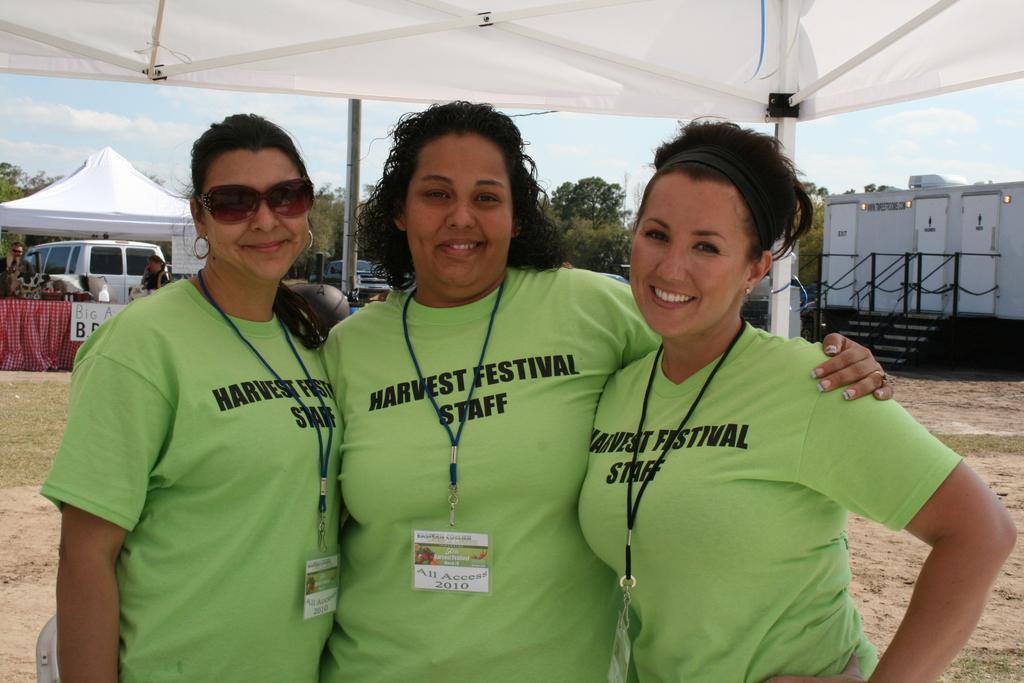Please provide a concise description of this image. This image is taken outdoors. At the top of the image there is a tent. In the background there are many trees and there is a sky with clouds. A few vehicles are parked on the ground. On the right side of the image there are a few restrooms and there is a railing. On the left side of the image there is a tent and there is a table with a tablecloth on it and there is a board with a text on it. In the middle of the image three women are standing on the ground and they are with smiling faces. 